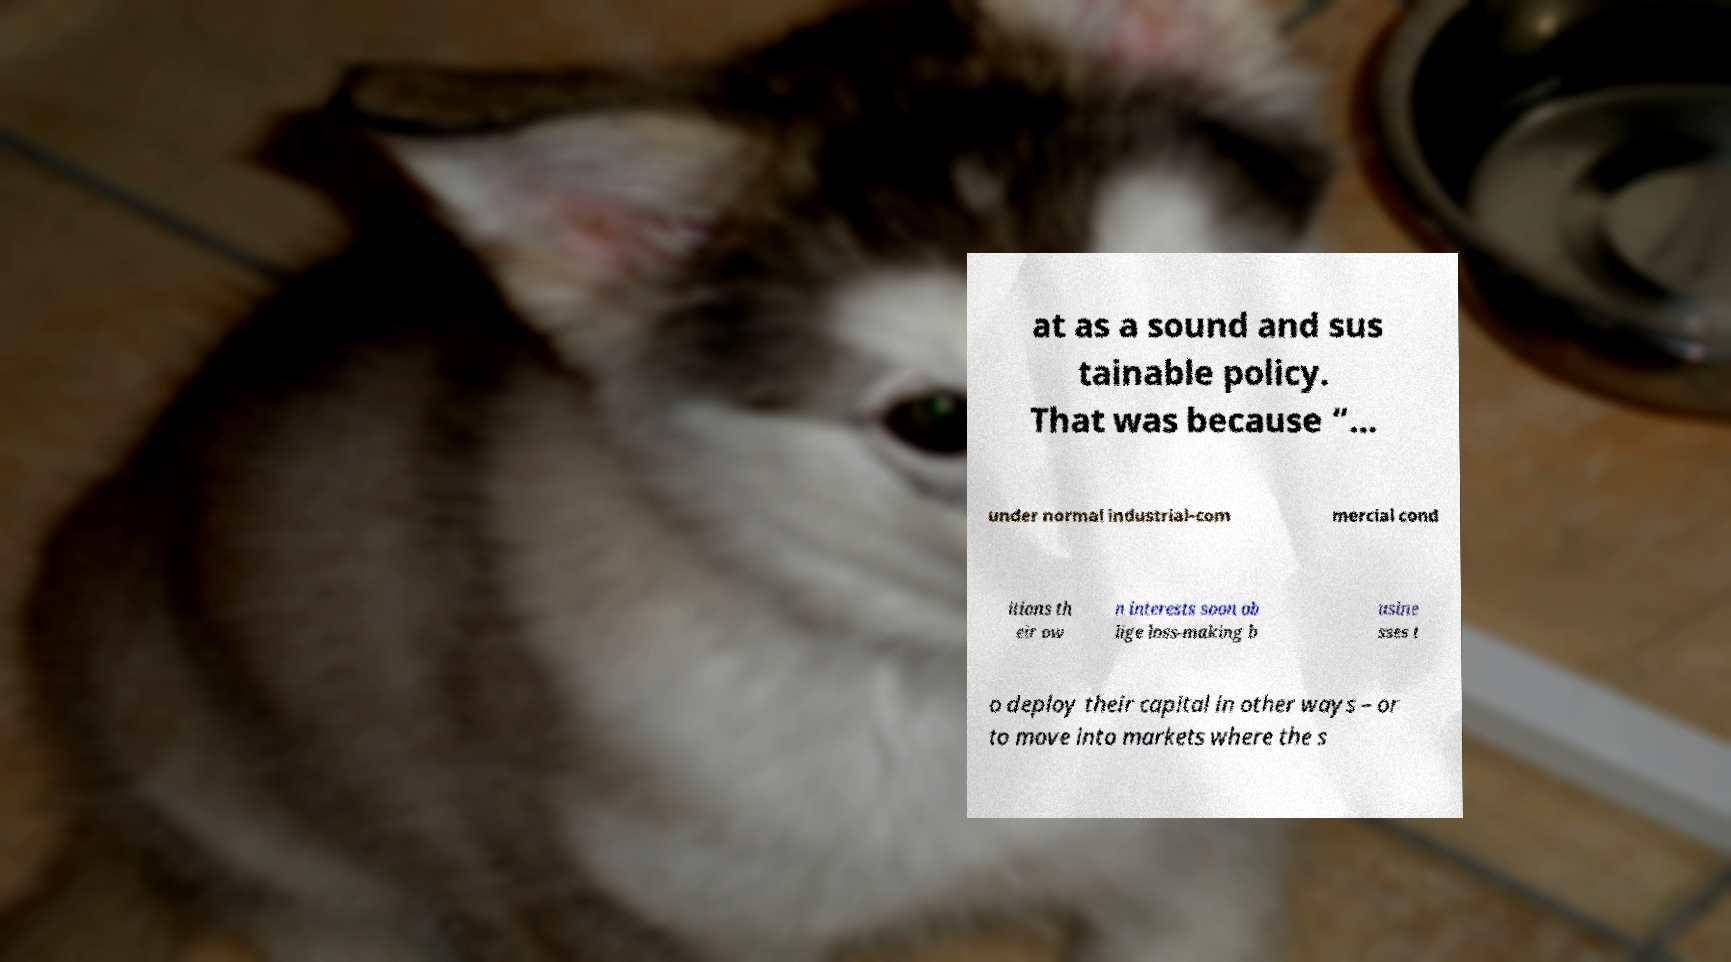Could you extract and type out the text from this image? at as a sound and sus tainable policy. That was because “… under normal industrial-com mercial cond itions th eir ow n interests soon ob lige loss-making b usine sses t o deploy their capital in other ways – or to move into markets where the s 